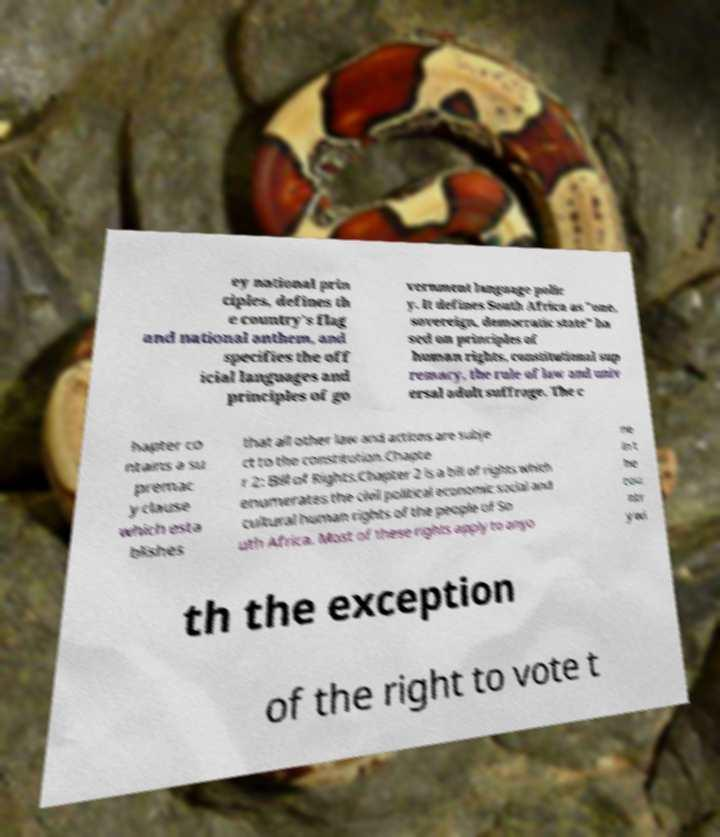Could you assist in decoding the text presented in this image and type it out clearly? ey national prin ciples, defines th e country's flag and national anthem, and specifies the off icial languages and principles of go vernment language polic y. It defines South Africa as "one, sovereign, democratic state" ba sed on principles of human rights, constitutional sup remacy, the rule of law and univ ersal adult suffrage. The c hapter co ntains a su premac y clause which esta blishes that all other law and actions are subje ct to the constitution.Chapte r 2: Bill of Rights.Chapter 2 is a bill of rights which enumerates the civil political economic social and cultural human rights of the people of So uth Africa. Most of these rights apply to anyo ne in t he cou ntr y wi th the exception of the right to vote t 